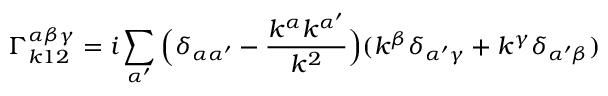Convert formula to latex. <formula><loc_0><loc_0><loc_500><loc_500>\Gamma _ { k 1 2 } ^ { \alpha \beta \gamma } = i \sum _ { \alpha ^ { \prime } } \left ( \delta _ { \alpha \alpha ^ { \prime } } - \frac { k ^ { \alpha } k ^ { \alpha ^ { \prime } } } { k ^ { 2 } } \right ) ( k ^ { \beta } \delta _ { \alpha ^ { \prime } \gamma } + k ^ { \gamma } \delta _ { \alpha ^ { \prime } \beta } )</formula> 